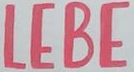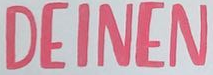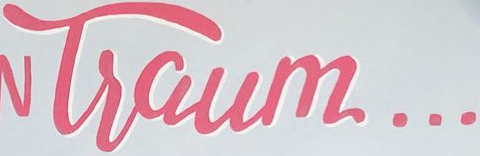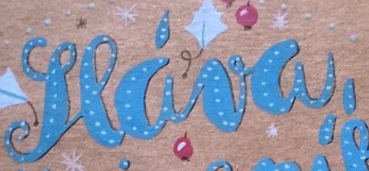What text appears in these images from left to right, separated by a semicolon? LEBE; DEINEN; Tsaum...; seáva, 